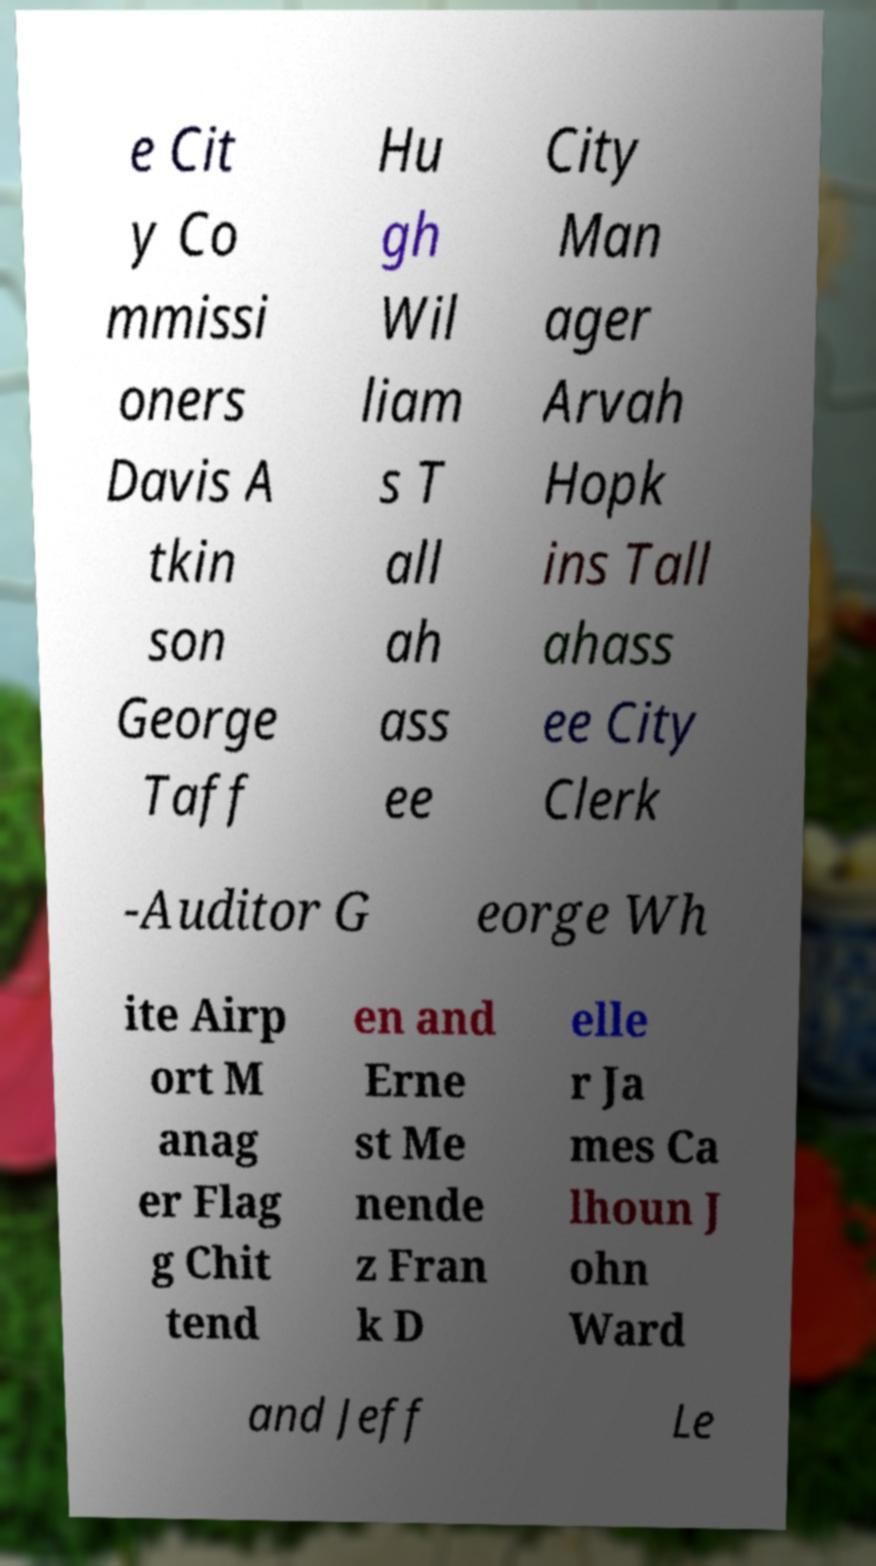Can you read and provide the text displayed in the image?This photo seems to have some interesting text. Can you extract and type it out for me? e Cit y Co mmissi oners Davis A tkin son George Taff Hu gh Wil liam s T all ah ass ee City Man ager Arvah Hopk ins Tall ahass ee City Clerk -Auditor G eorge Wh ite Airp ort M anag er Flag g Chit tend en and Erne st Me nende z Fran k D elle r Ja mes Ca lhoun J ohn Ward and Jeff Le 